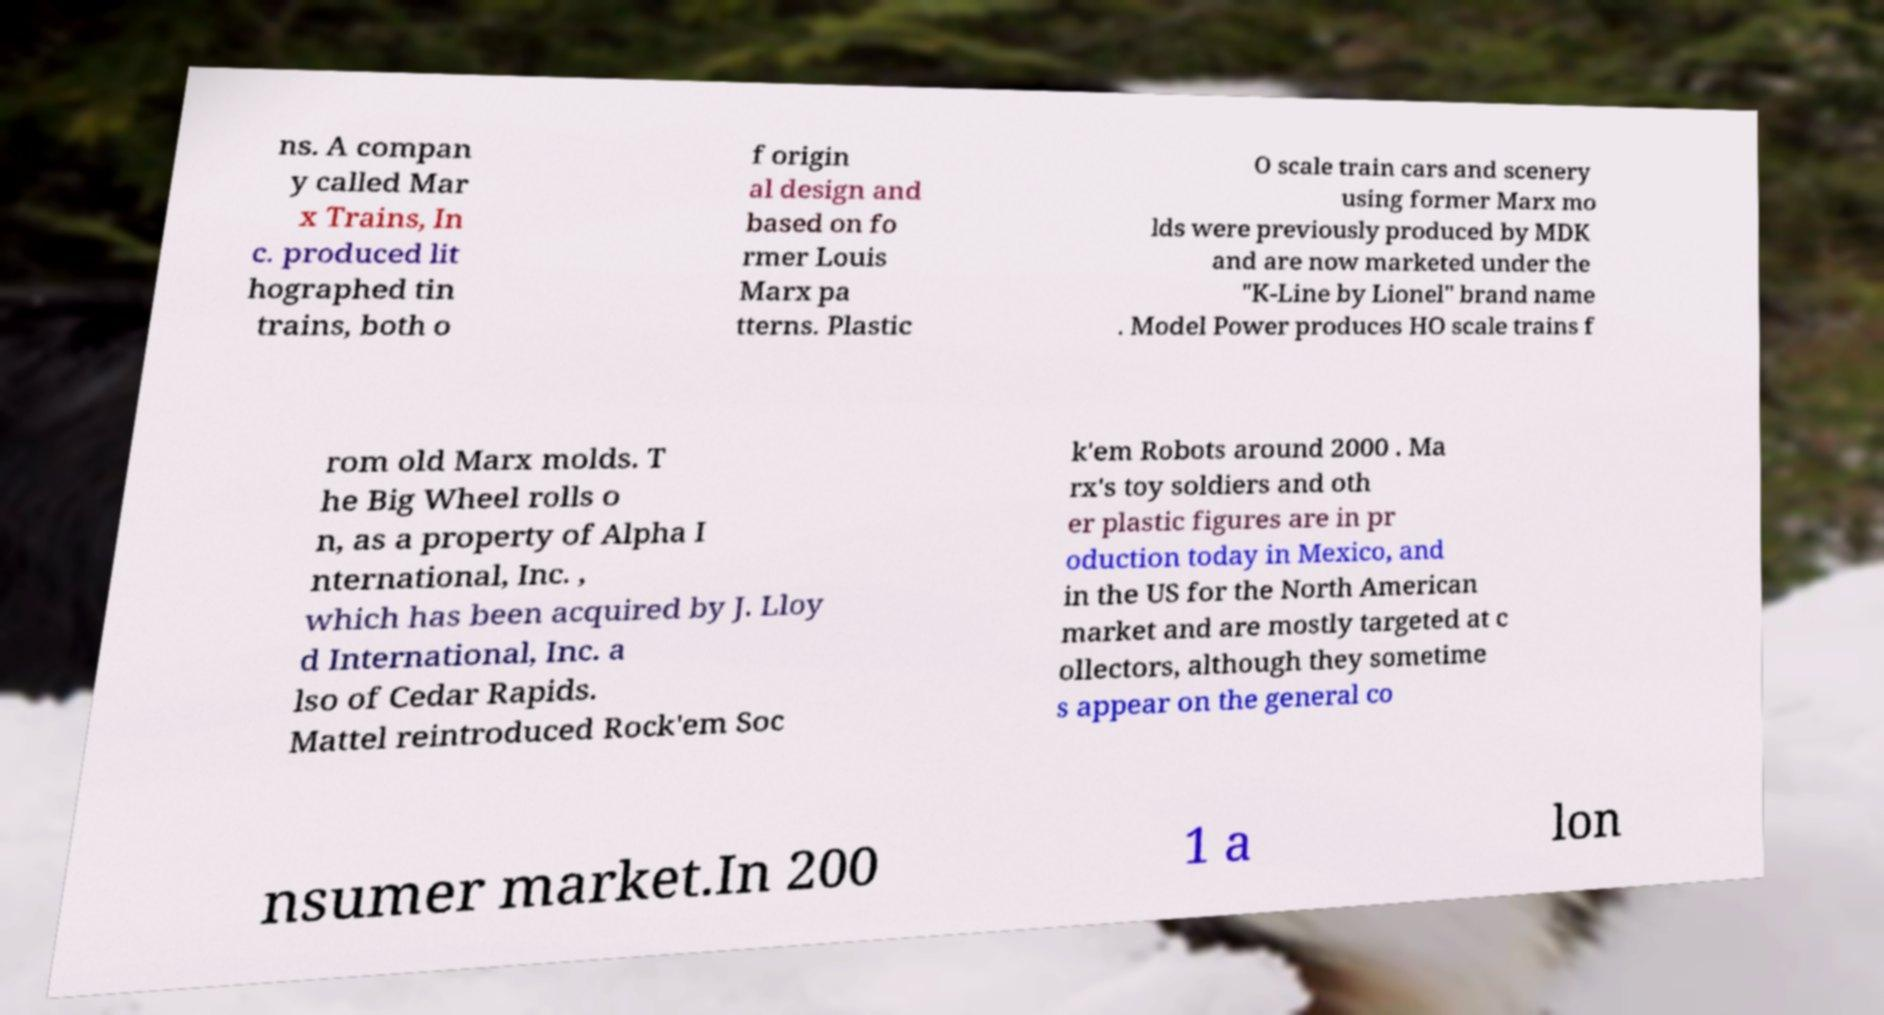Could you extract and type out the text from this image? ns. A compan y called Mar x Trains, In c. produced lit hographed tin trains, both o f origin al design and based on fo rmer Louis Marx pa tterns. Plastic O scale train cars and scenery using former Marx mo lds were previously produced by MDK and are now marketed under the "K-Line by Lionel" brand name . Model Power produces HO scale trains f rom old Marx molds. T he Big Wheel rolls o n, as a property of Alpha I nternational, Inc. , which has been acquired by J. Lloy d International, Inc. a lso of Cedar Rapids. Mattel reintroduced Rock'em Soc k'em Robots around 2000 . Ma rx's toy soldiers and oth er plastic figures are in pr oduction today in Mexico, and in the US for the North American market and are mostly targeted at c ollectors, although they sometime s appear on the general co nsumer market.In 200 1 a lon 